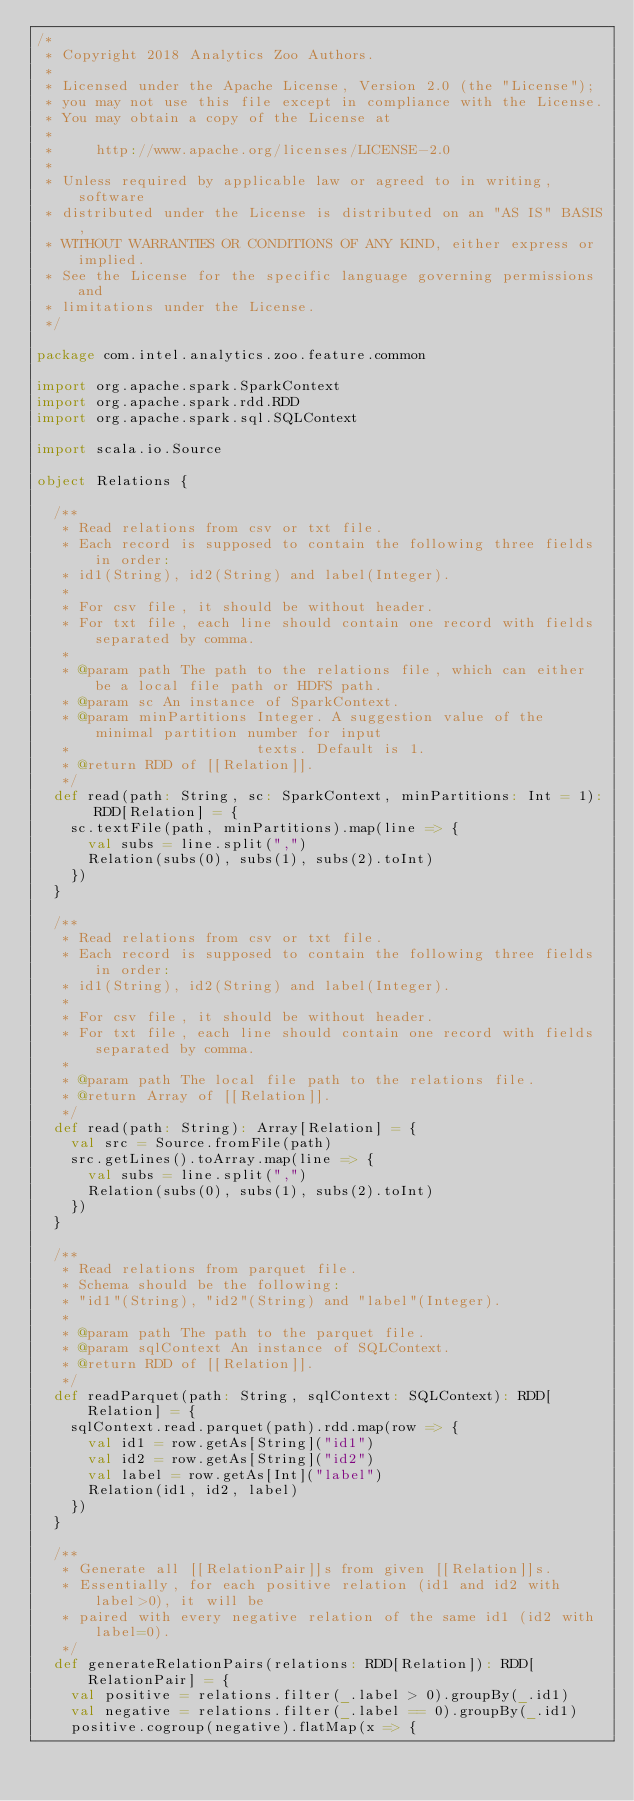<code> <loc_0><loc_0><loc_500><loc_500><_Scala_>/*
 * Copyright 2018 Analytics Zoo Authors.
 *
 * Licensed under the Apache License, Version 2.0 (the "License");
 * you may not use this file except in compliance with the License.
 * You may obtain a copy of the License at
 *
 *     http://www.apache.org/licenses/LICENSE-2.0
 *
 * Unless required by applicable law or agreed to in writing, software
 * distributed under the License is distributed on an "AS IS" BASIS,
 * WITHOUT WARRANTIES OR CONDITIONS OF ANY KIND, either express or implied.
 * See the License for the specific language governing permissions and
 * limitations under the License.
 */

package com.intel.analytics.zoo.feature.common

import org.apache.spark.SparkContext
import org.apache.spark.rdd.RDD
import org.apache.spark.sql.SQLContext

import scala.io.Source

object Relations {

  /**
   * Read relations from csv or txt file.
   * Each record is supposed to contain the following three fields in order:
   * id1(String), id2(String) and label(Integer).
   *
   * For csv file, it should be without header.
   * For txt file, each line should contain one record with fields separated by comma.
   *
   * @param path The path to the relations file, which can either be a local file path or HDFS path.
   * @param sc An instance of SparkContext.
   * @param minPartitions Integer. A suggestion value of the minimal partition number for input
   *                      texts. Default is 1.
   * @return RDD of [[Relation]].
   */
  def read(path: String, sc: SparkContext, minPartitions: Int = 1): RDD[Relation] = {
    sc.textFile(path, minPartitions).map(line => {
      val subs = line.split(",")
      Relation(subs(0), subs(1), subs(2).toInt)
    })
  }

  /**
   * Read relations from csv or txt file.
   * Each record is supposed to contain the following three fields in order:
   * id1(String), id2(String) and label(Integer).
   *
   * For csv file, it should be without header.
   * For txt file, each line should contain one record with fields separated by comma.
   *
   * @param path The local file path to the relations file.
   * @return Array of [[Relation]].
   */
  def read(path: String): Array[Relation] = {
    val src = Source.fromFile(path)
    src.getLines().toArray.map(line => {
      val subs = line.split(",")
      Relation(subs(0), subs(1), subs(2).toInt)
    })
  }

  /**
   * Read relations from parquet file.
   * Schema should be the following:
   * "id1"(String), "id2"(String) and "label"(Integer).
   *
   * @param path The path to the parquet file.
   * @param sqlContext An instance of SQLContext.
   * @return RDD of [[Relation]].
   */
  def readParquet(path: String, sqlContext: SQLContext): RDD[Relation] = {
    sqlContext.read.parquet(path).rdd.map(row => {
      val id1 = row.getAs[String]("id1")
      val id2 = row.getAs[String]("id2")
      val label = row.getAs[Int]("label")
      Relation(id1, id2, label)
    })
  }

  /**
   * Generate all [[RelationPair]]s from given [[Relation]]s.
   * Essentially, for each positive relation (id1 and id2 with label>0), it will be
   * paired with every negative relation of the same id1 (id2 with label=0).
   */
  def generateRelationPairs(relations: RDD[Relation]): RDD[RelationPair] = {
    val positive = relations.filter(_.label > 0).groupBy(_.id1)
    val negative = relations.filter(_.label == 0).groupBy(_.id1)
    positive.cogroup(negative).flatMap(x => {</code> 